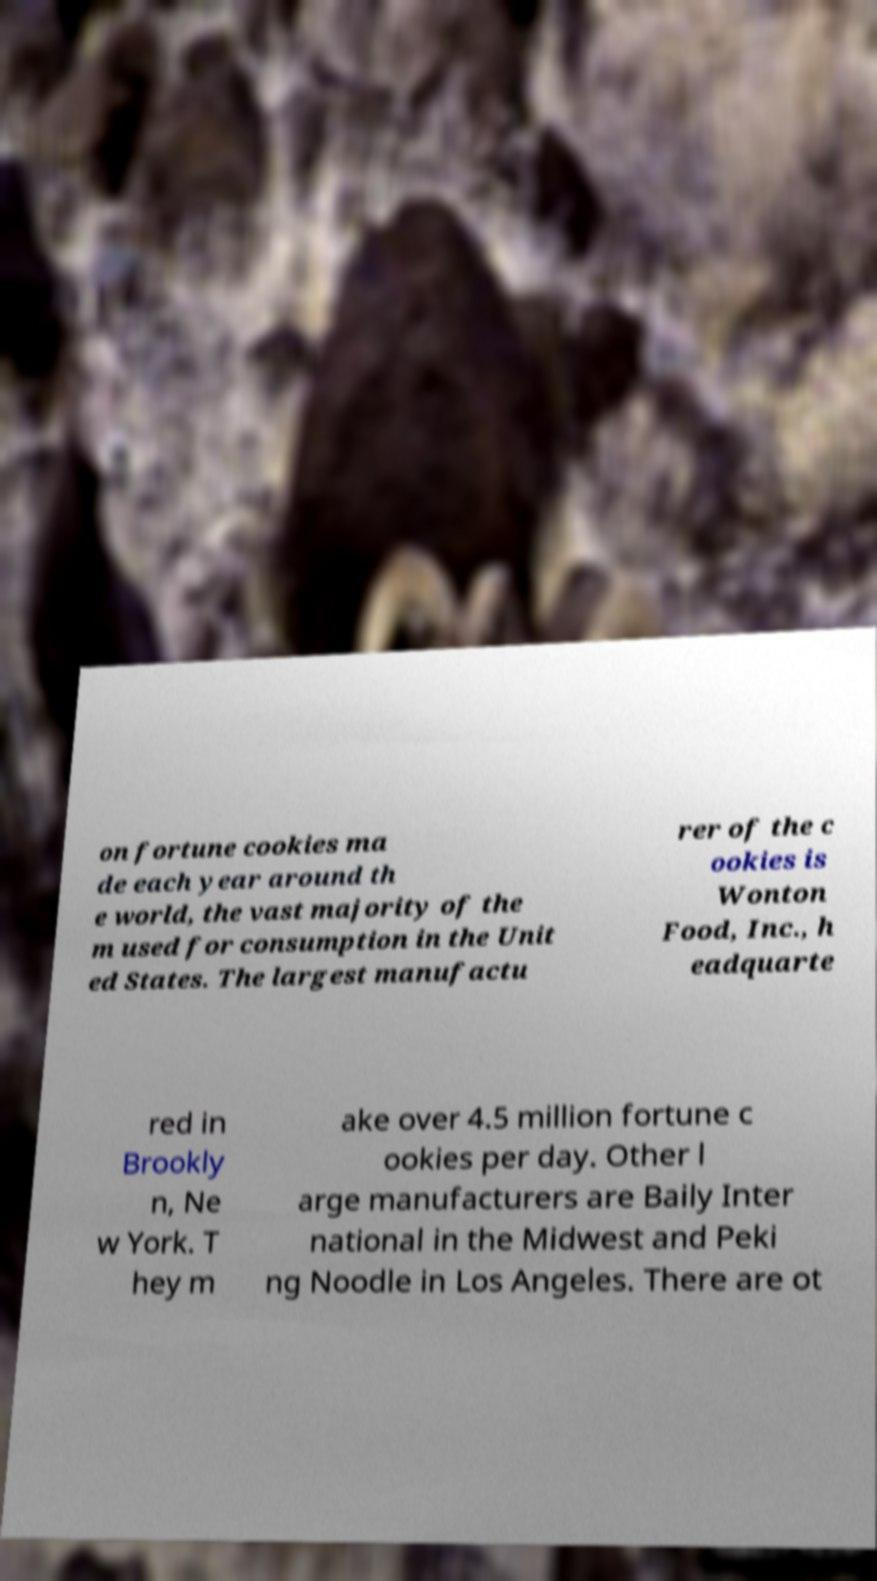I need the written content from this picture converted into text. Can you do that? on fortune cookies ma de each year around th e world, the vast majority of the m used for consumption in the Unit ed States. The largest manufactu rer of the c ookies is Wonton Food, Inc., h eadquarte red in Brookly n, Ne w York. T hey m ake over 4.5 million fortune c ookies per day. Other l arge manufacturers are Baily Inter national in the Midwest and Peki ng Noodle in Los Angeles. There are ot 